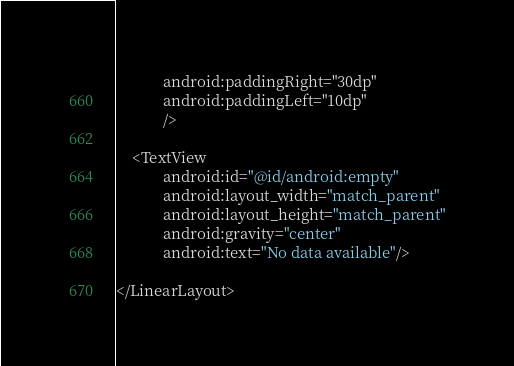<code> <loc_0><loc_0><loc_500><loc_500><_XML_>            android:paddingRight="30dp"
            android:paddingLeft="10dp"
            />

    <TextView
            android:id="@id/android:empty"
            android:layout_width="match_parent"
            android:layout_height="match_parent"
            android:gravity="center"
            android:text="No data available"/>

</LinearLayout></code> 